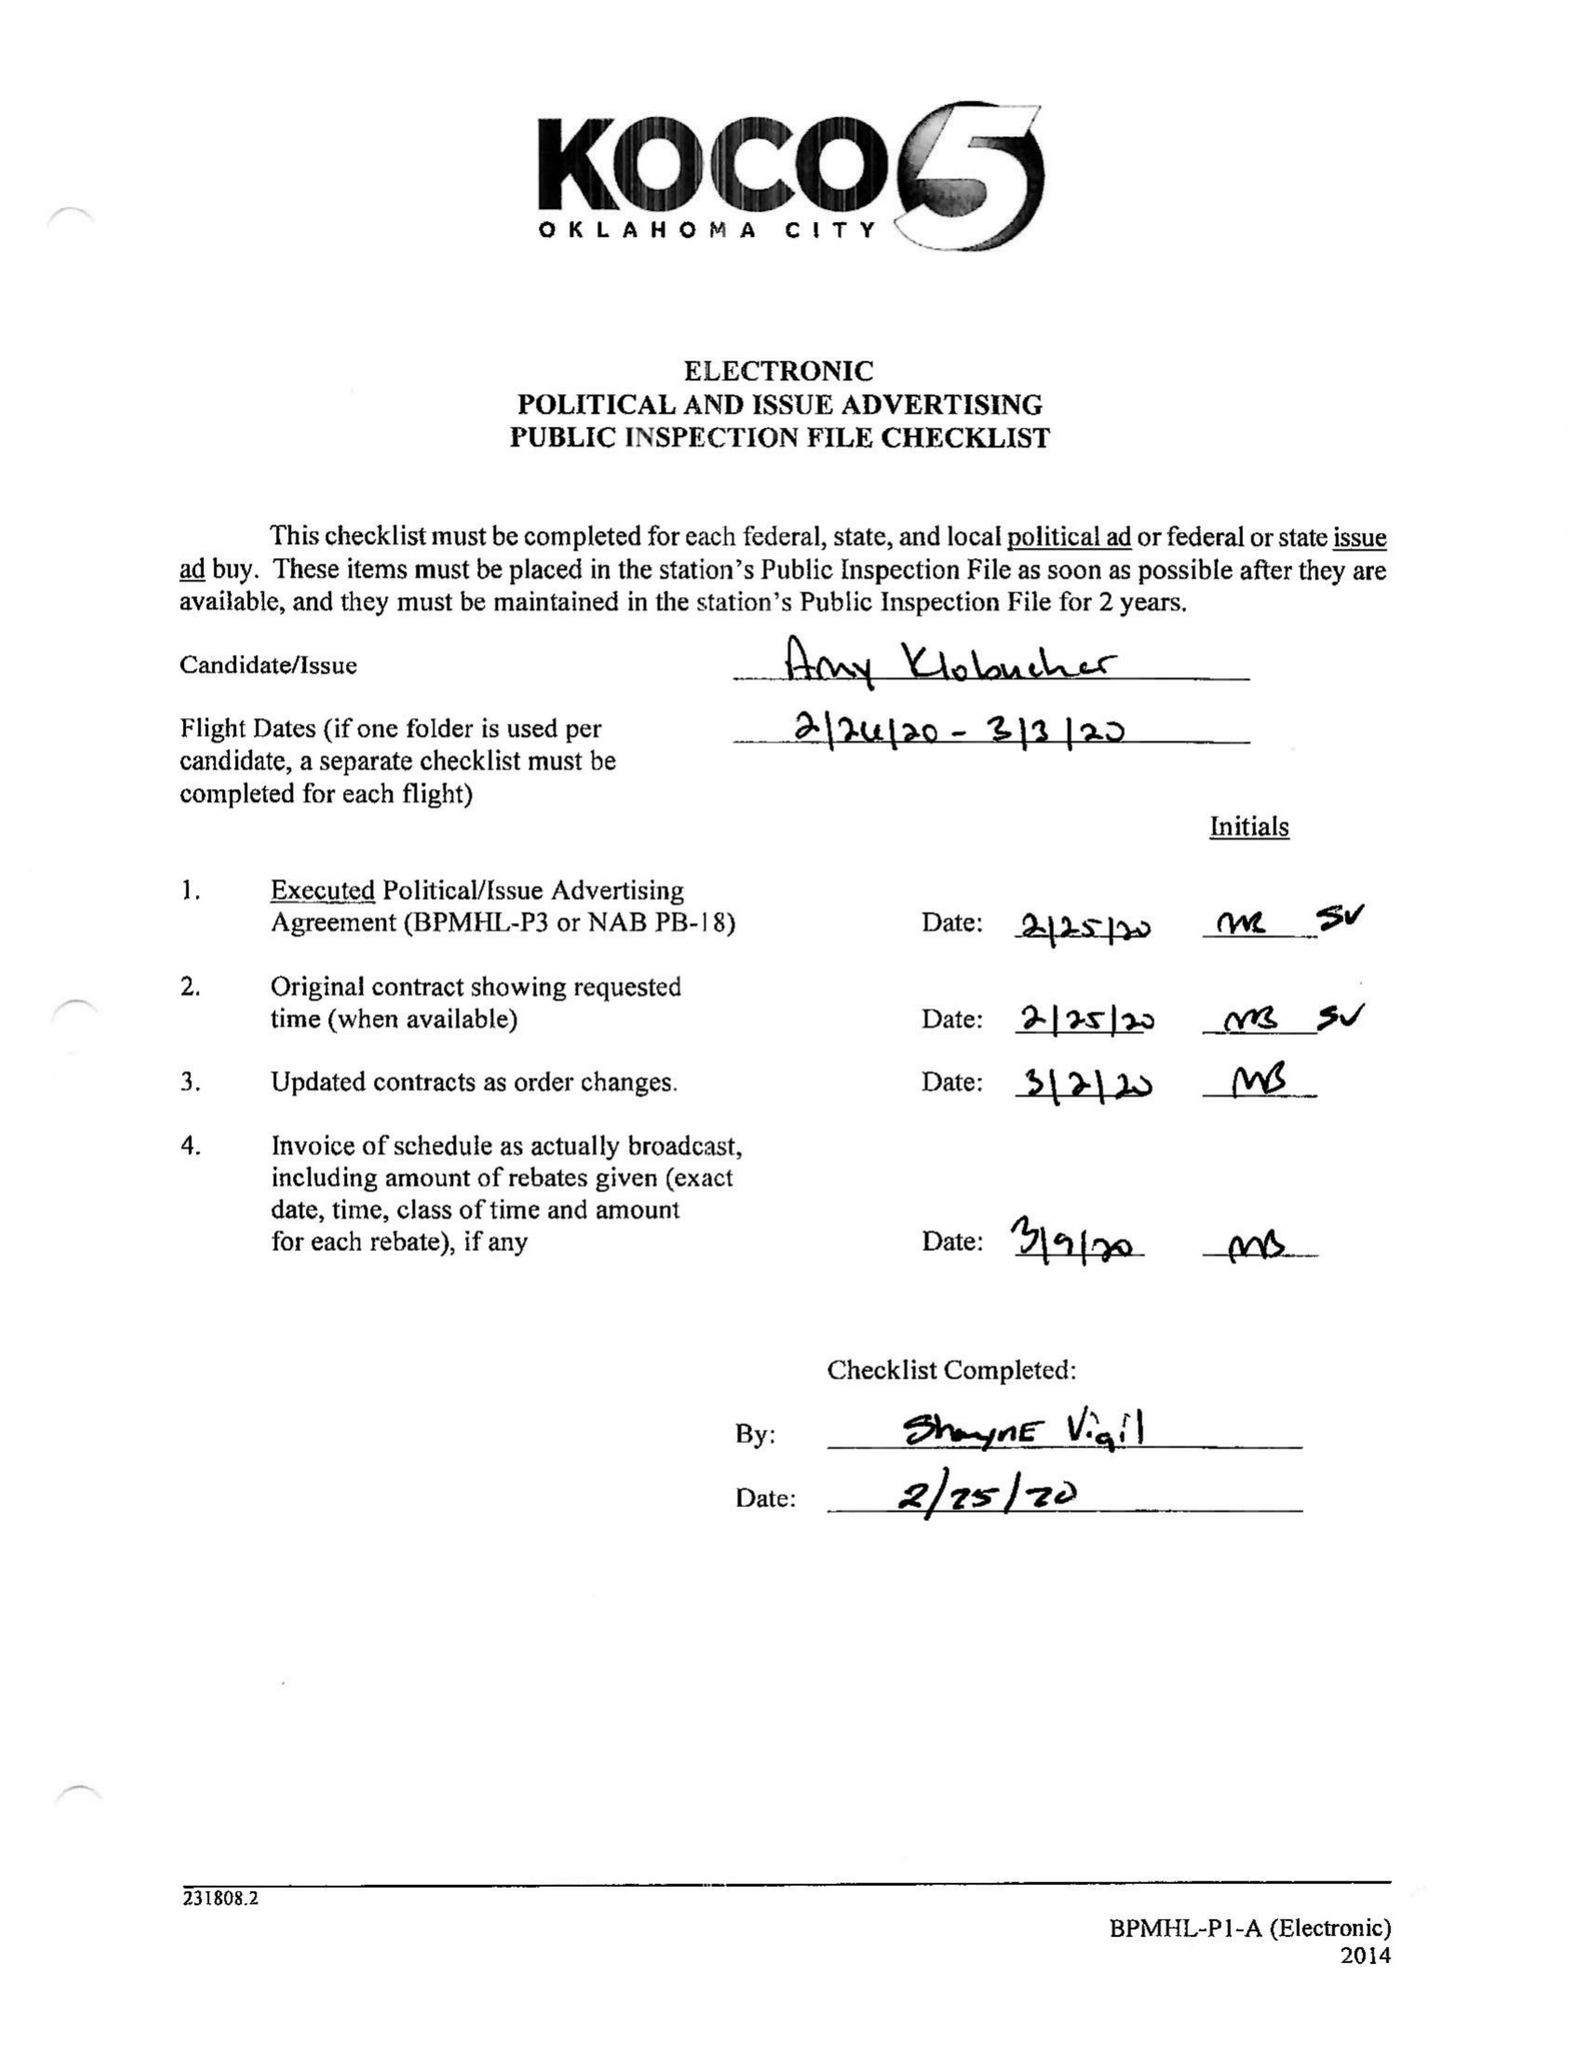What is the value for the flight_to?
Answer the question using a single word or phrase. 03/03/20 